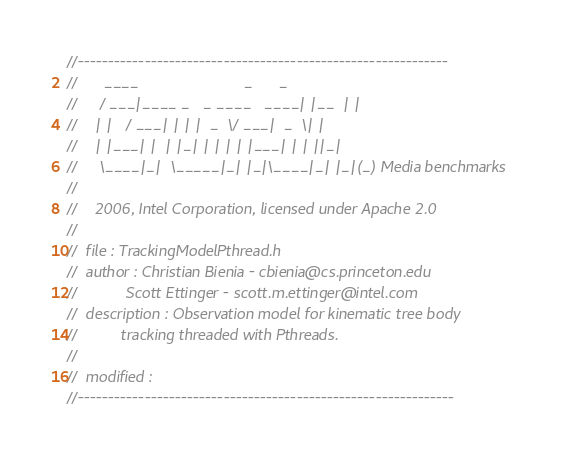<code> <loc_0><loc_0><loc_500><loc_500><_C_>//-------------------------------------------------------------
//      ____                        _      _
//     / ___|____ _   _ ____   ____| |__  | |
//    | |   / ___| | | |  _  \/ ___|  _  \| |
//    | |___| |  | |_| | | | | |___| | | ||_|
//     \____|_|  \_____|_| |_|\____|_| |_|(_) Media benchmarks
//                  
//	  2006, Intel Corporation, licensed under Apache 2.0 
//
//  file : TrackingModelPthread.h
//  author : Christian Bienia - cbienia@cs.princeton.edu
//			 Scott Ettinger - scott.m.ettinger@intel.com
//  description : Observation model for kinematic tree body 
//			tracking threaded with Pthreads.
//				  
//  modified : 
//--------------------------------------------------------------
</code> 